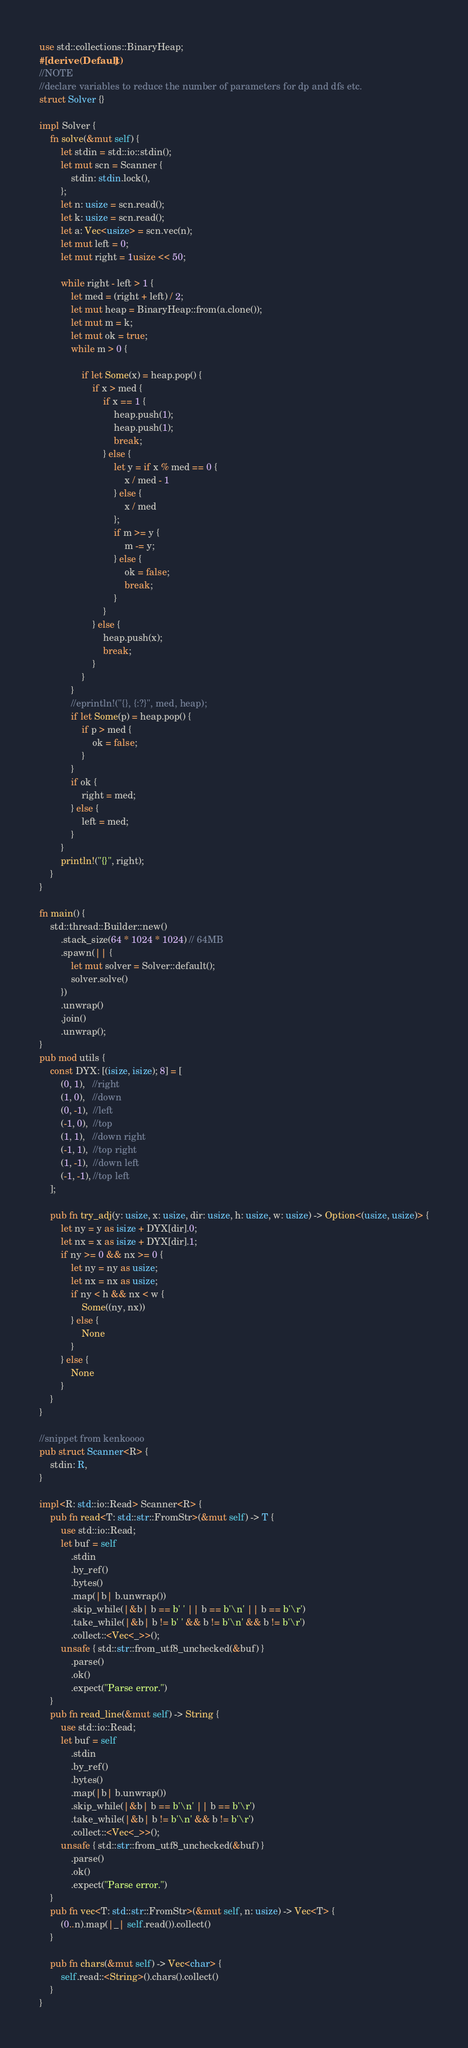<code> <loc_0><loc_0><loc_500><loc_500><_Rust_>use std::collections::BinaryHeap;
#[derive(Default)]
//NOTE
//declare variables to reduce the number of parameters for dp and dfs etc.
struct Solver {}

impl Solver {
    fn solve(&mut self) {
        let stdin = std::io::stdin();
        let mut scn = Scanner {
            stdin: stdin.lock(),
        };
        let n: usize = scn.read();
        let k: usize = scn.read();
        let a: Vec<usize> = scn.vec(n);
        let mut left = 0;
        let mut right = 1usize << 50;

        while right - left > 1 {
            let med = (right + left) / 2;
            let mut heap = BinaryHeap::from(a.clone());
            let mut m = k;
            let mut ok = true;
            while m > 0 {

                if let Some(x) = heap.pop() {
                    if x > med {
                        if x == 1 {
                            heap.push(1);
                            heap.push(1);
                            break;
                        } else {
                            let y = if x % med == 0 {
                                x / med - 1
                            } else {
                                x / med
                            };
                            if m >= y {
                                m -= y;
                            } else {
                                ok = false;
                                break;
                            }
                        }
                    } else {
                        heap.push(x);
                        break;
                    }
                }
            }
            //eprintln!("{}, {:?}", med, heap);
            if let Some(p) = heap.pop() {
                if p > med {
                    ok = false;
                }
            }
            if ok {
                right = med;
            } else {
                left = med;
            }
        }
        println!("{}", right);
    }
}

fn main() {
    std::thread::Builder::new()
        .stack_size(64 * 1024 * 1024) // 64MB
        .spawn(|| {
            let mut solver = Solver::default();
            solver.solve()
        })
        .unwrap()
        .join()
        .unwrap();
}
pub mod utils {
    const DYX: [(isize, isize); 8] = [
        (0, 1),   //right
        (1, 0),   //down
        (0, -1),  //left
        (-1, 0),  //top
        (1, 1),   //down right
        (-1, 1),  //top right
        (1, -1),  //down left
        (-1, -1), //top left
    ];

    pub fn try_adj(y: usize, x: usize, dir: usize, h: usize, w: usize) -> Option<(usize, usize)> {
        let ny = y as isize + DYX[dir].0;
        let nx = x as isize + DYX[dir].1;
        if ny >= 0 && nx >= 0 {
            let ny = ny as usize;
            let nx = nx as usize;
            if ny < h && nx < w {
                Some((ny, nx))
            } else {
                None
            }
        } else {
            None
        }
    }
}

//snippet from kenkoooo
pub struct Scanner<R> {
    stdin: R,
}

impl<R: std::io::Read> Scanner<R> {
    pub fn read<T: std::str::FromStr>(&mut self) -> T {
        use std::io::Read;
        let buf = self
            .stdin
            .by_ref()
            .bytes()
            .map(|b| b.unwrap())
            .skip_while(|&b| b == b' ' || b == b'\n' || b == b'\r')
            .take_while(|&b| b != b' ' && b != b'\n' && b != b'\r')
            .collect::<Vec<_>>();
        unsafe { std::str::from_utf8_unchecked(&buf) }
            .parse()
            .ok()
            .expect("Parse error.")
    }
    pub fn read_line(&mut self) -> String {
        use std::io::Read;
        let buf = self
            .stdin
            .by_ref()
            .bytes()
            .map(|b| b.unwrap())
            .skip_while(|&b| b == b'\n' || b == b'\r')
            .take_while(|&b| b != b'\n' && b != b'\r')
            .collect::<Vec<_>>();
        unsafe { std::str::from_utf8_unchecked(&buf) }
            .parse()
            .ok()
            .expect("Parse error.")
    }
    pub fn vec<T: std::str::FromStr>(&mut self, n: usize) -> Vec<T> {
        (0..n).map(|_| self.read()).collect()
    }

    pub fn chars(&mut self) -> Vec<char> {
        self.read::<String>().chars().collect()
    }
}
</code> 